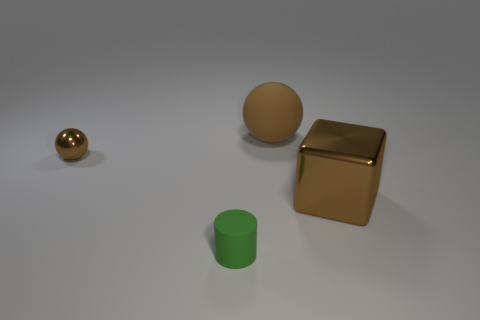There is a metal cube that is the same color as the matte sphere; what size is it?
Your response must be concise. Large. What number of other objects are there of the same size as the green rubber thing?
Keep it short and to the point. 1. What number of tiny objects are matte cylinders or brown shiny things?
Your answer should be very brief. 2. Do the brown shiny block and the brown metallic sphere that is behind the rubber cylinder have the same size?
Your answer should be compact. No. What number of other objects are there of the same shape as the small green matte object?
Make the answer very short. 0. What is the shape of the large brown thing that is made of the same material as the tiny brown sphere?
Offer a terse response. Cube. Are any large cyan metal spheres visible?
Your response must be concise. No. Is the number of big brown matte things to the left of the big matte sphere less than the number of things in front of the brown metallic sphere?
Offer a very short reply. Yes. There is a shiny object that is in front of the tiny metal ball; what is its shape?
Give a very brief answer. Cube. Does the small green object have the same material as the big brown cube?
Your response must be concise. No. 